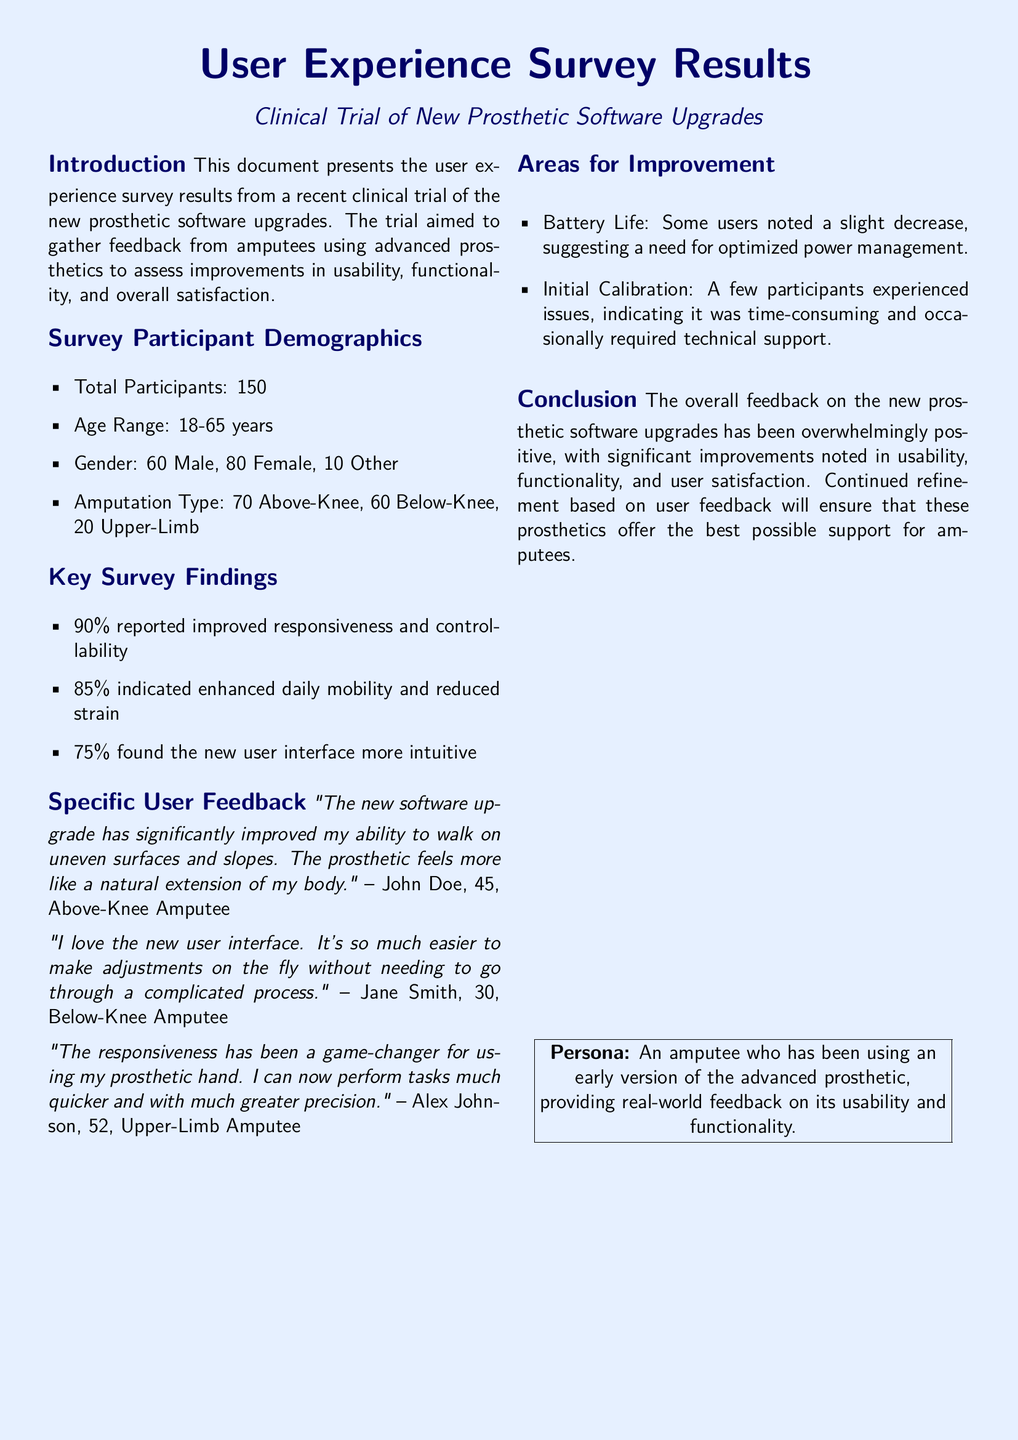What is the total number of survey participants? The document states that there were 150 total survey participants.
Answer: 150 What percentage of participants reported improved responsiveness? According to the findings, 90% of participants reported improved responsiveness and controllability.
Answer: 90% How many above-knee amputees participated in the survey? The document lists that there were 70 above-knee amputees among the participants.
Answer: 70 What specific feedback did John Doe provide? John Doe mentioned that the new software upgrade significantly improved his ability to walk on uneven surfaces and slopes.
Answer: Improved ability to walk on uneven surfaces What area for improvement was noted regarding battery life? Some users noted a slight decrease in battery life, suggesting a need for optimized power management.
Answer: Optimized power management What was the age range of the participants? The age range of the participants was stated as 18 to 65 years.
Answer: 18-65 years What percentage of participants indicated enhanced daily mobility? The survey results indicated that 85% of participants indicated enhanced daily mobility and reduced strain.
Answer: 85% What specific issue was highlighted regarding initial calibration? It was noted that a few participants experienced issues indicating it was time-consuming and occasionally required technical support.
Answer: Time-consuming calibration Which gender had the most participants in the survey? The survey results show that there were 80 female participants, which is more than any other gender.
Answer: Female 